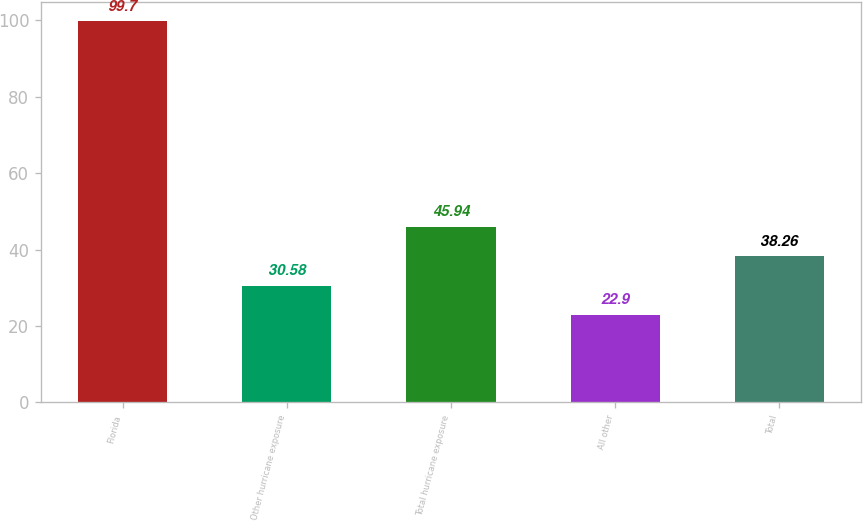Convert chart to OTSL. <chart><loc_0><loc_0><loc_500><loc_500><bar_chart><fcel>Florida<fcel>Other hurricane exposure<fcel>Total hurricane exposure<fcel>All other<fcel>Total<nl><fcel>99.7<fcel>30.58<fcel>45.94<fcel>22.9<fcel>38.26<nl></chart> 